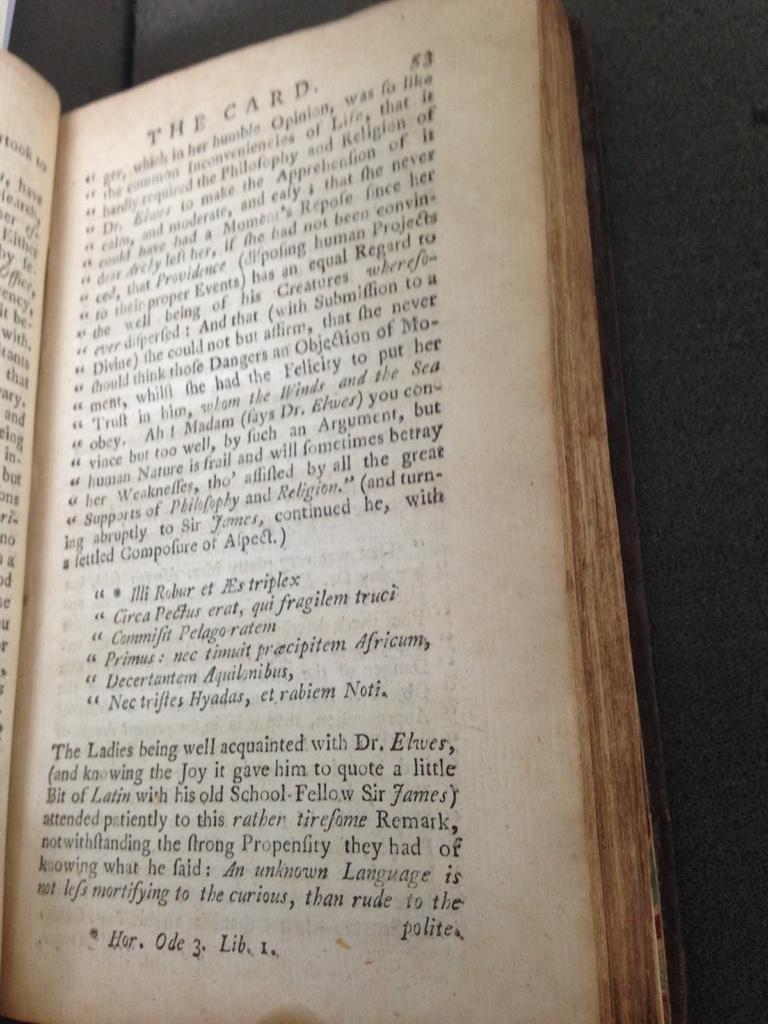<image>
Present a compact description of the photo's key features. A book opened to page 53 with The Card written at the top. 